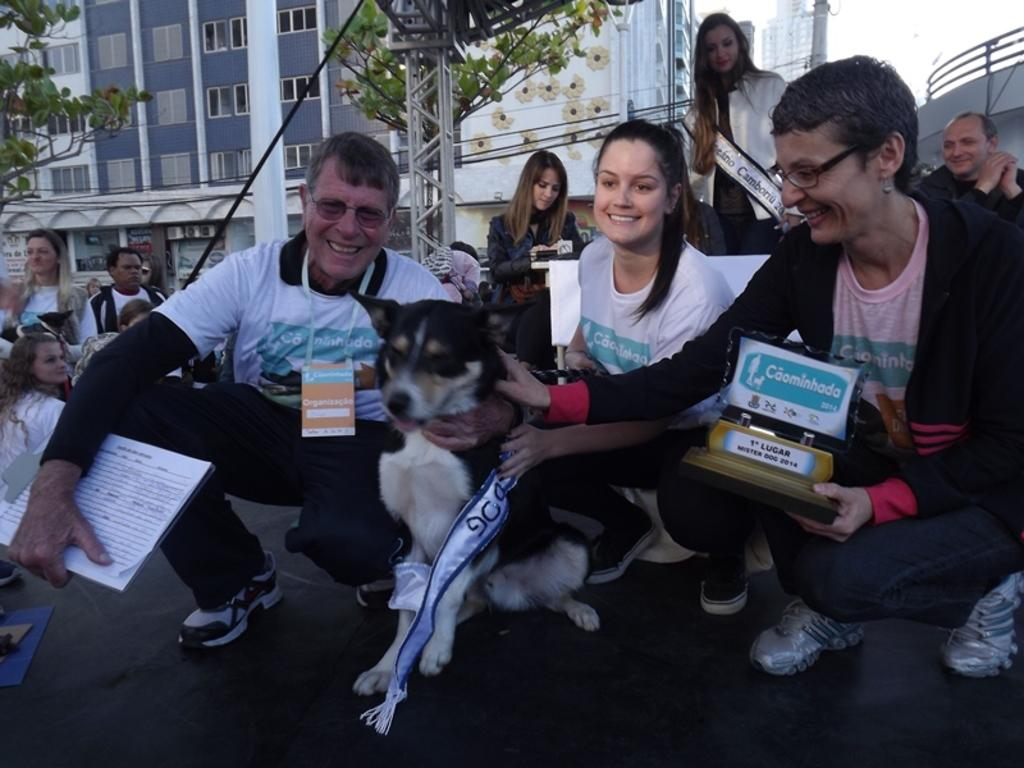What type of scene is depicted in the image? The image is an outdoor scene. What is the person holding in the image? The person is holding a dog, a book, and a shield. Can you describe the building in the image? There is a building with windows in the image. What other objects can be seen in the image? There is a pole and a tree in the image. What is the person's posture in the image? The person is standing. What type of vest is the person wearing in the image? There is no vest visible in the image. Is there a bridge in the image? No, there is no bridge present in the image. 